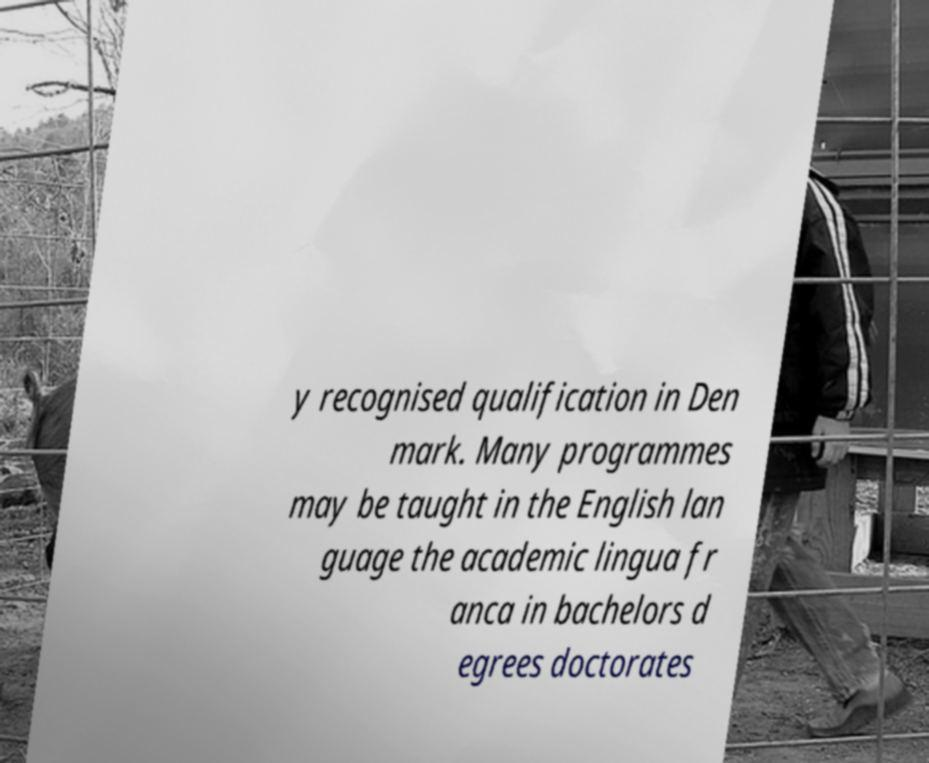Can you read and provide the text displayed in the image?This photo seems to have some interesting text. Can you extract and type it out for me? y recognised qualification in Den mark. Many programmes may be taught in the English lan guage the academic lingua fr anca in bachelors d egrees doctorates 